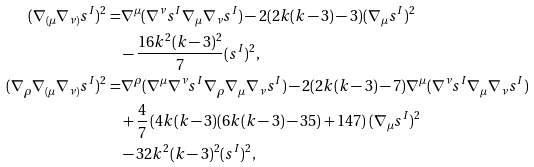<formula> <loc_0><loc_0><loc_500><loc_500>( \nabla _ { ( \mu } \nabla _ { \nu ) } s ^ { I } ) ^ { 2 } = & \nabla ^ { \mu } ( \nabla ^ { \nu } s ^ { I } \nabla _ { \mu } \nabla _ { \nu } s ^ { I } ) - 2 ( 2 k ( k - 3 ) - 3 ) ( \nabla _ { \mu } s ^ { I } ) ^ { 2 } \\ & - \frac { 1 6 k ^ { 2 } ( k - 3 ) ^ { 2 } } { 7 } ( s ^ { I } ) ^ { 2 } , \\ ( \nabla _ { \rho } \nabla _ { ( \mu } \nabla _ { \nu ) } s ^ { I } ) ^ { 2 } = & \nabla ^ { \rho } ( \nabla ^ { \mu } \nabla ^ { \nu } s ^ { I } \nabla _ { \rho } \nabla _ { \mu } \nabla _ { \nu } s ^ { I } ) - 2 ( 2 k ( k - 3 ) - 7 ) \nabla ^ { \mu } ( \nabla ^ { \nu } s ^ { I } \nabla _ { \mu } \nabla _ { \nu } s ^ { I } ) \\ & + \frac { 4 } { 7 } \left ( 4 k ( k - 3 ) ( 6 k ( k - 3 ) - 3 5 ) + 1 4 7 \right ) ( \nabla _ { \mu } s ^ { I } ) ^ { 2 } \\ & - 3 2 k ^ { 2 } ( k - 3 ) ^ { 2 } ( s ^ { I } ) ^ { 2 } ,</formula> 